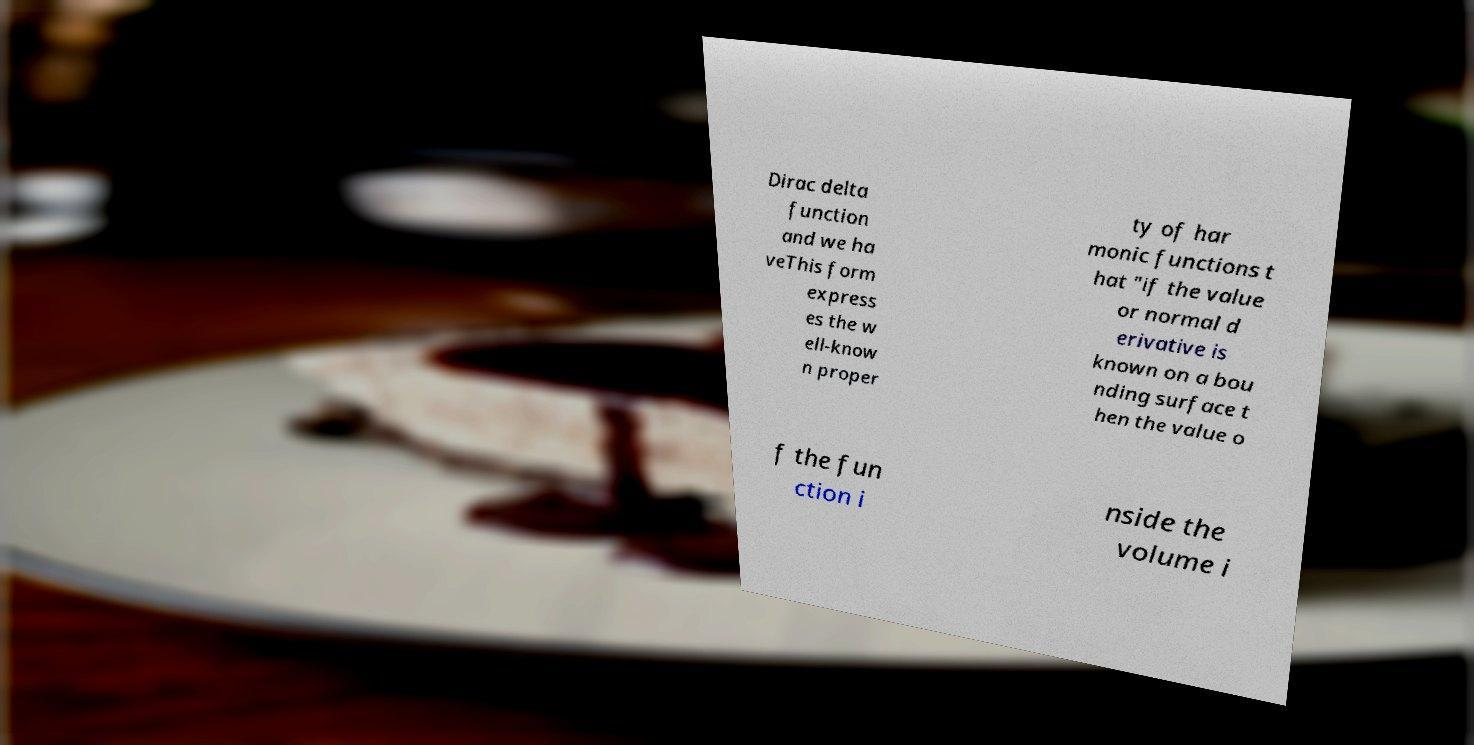There's text embedded in this image that I need extracted. Can you transcribe it verbatim? Dirac delta function and we ha veThis form express es the w ell-know n proper ty of har monic functions t hat "if the value or normal d erivative is known on a bou nding surface t hen the value o f the fun ction i nside the volume i 